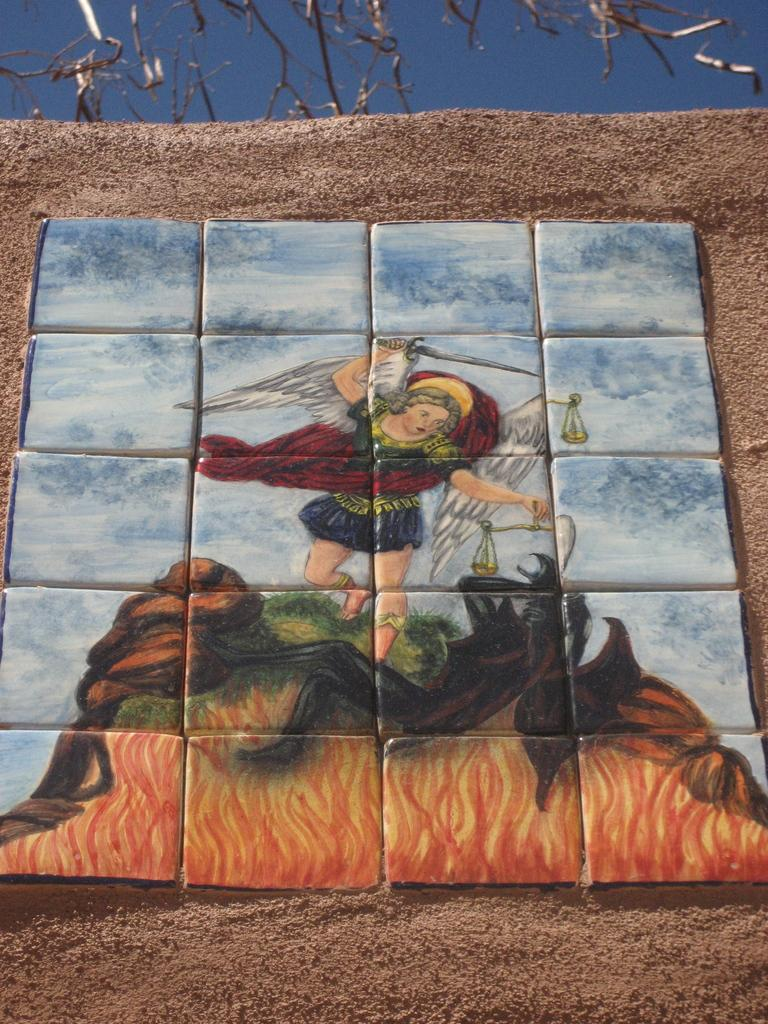What is the main subject of the wall painting in the image? The wall painting depicts a person. What is the background of the wall painting? The background of the wall painting is not mentioned in the facts, but we can see that there is sand visible at the bottom of the image. What type of seat can be seen in the image? There is no seat present in the image. What action is the person in the wall painting performing? The facts do not mention any specific action being performed by the person in the wall painting. 